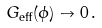<formula> <loc_0><loc_0><loc_500><loc_500>G _ { \text {eff} } ( \phi ) \to 0 \, .</formula> 